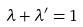Convert formula to latex. <formula><loc_0><loc_0><loc_500><loc_500>\lambda + \lambda ^ { \prime } = 1</formula> 